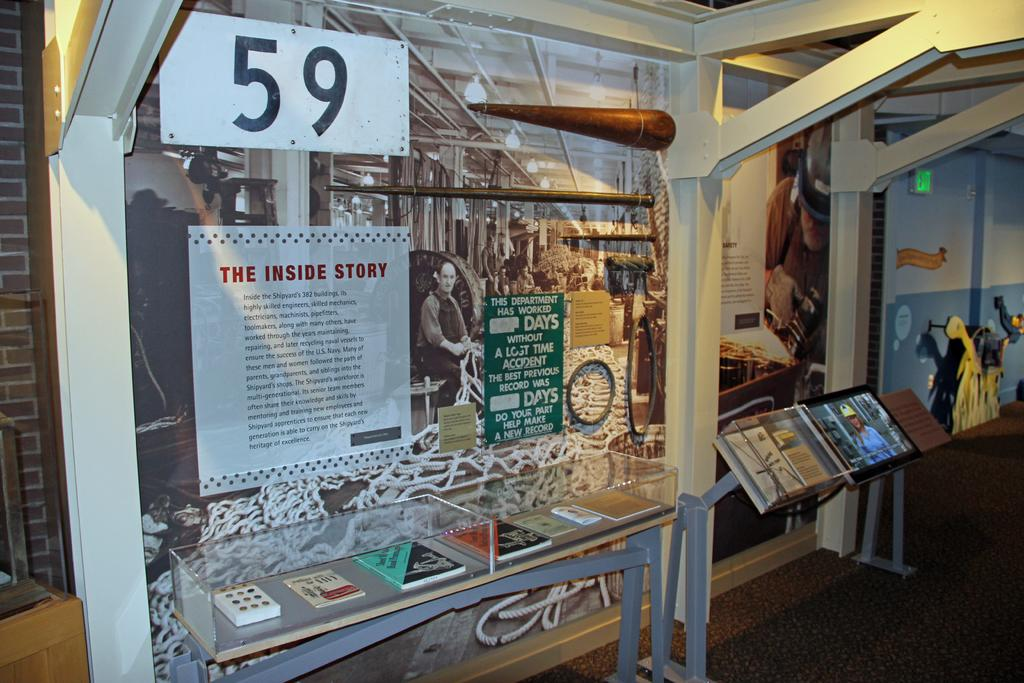What type of visuals can be seen in the image? There are posters and images in the image. What structure is present in the image? There is a glass rack in the image. What architectural elements can be observed in the image? There are pillars in the image. What type of surface is visible at the bottom of the image? There is a floor at the bottom of the image. What other objects are present in the image? There are objects and a signboard in the image. What is the background of the image made of? There is a wall in the image. How many friends are sitting on the floor in the image? There are no friends sitting on the floor in the image. What type of bulb is used to light up the posters in the image? There is no information about the type of bulb used to light up the posters in the image. 